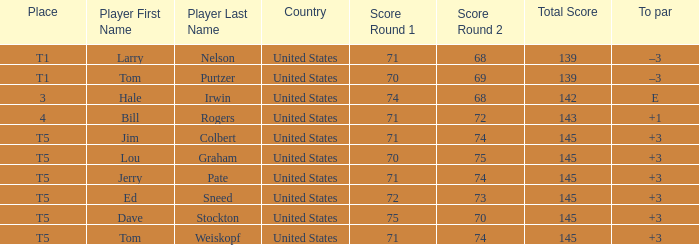Who is the player with a 70-75=145 score? Lou Graham. 